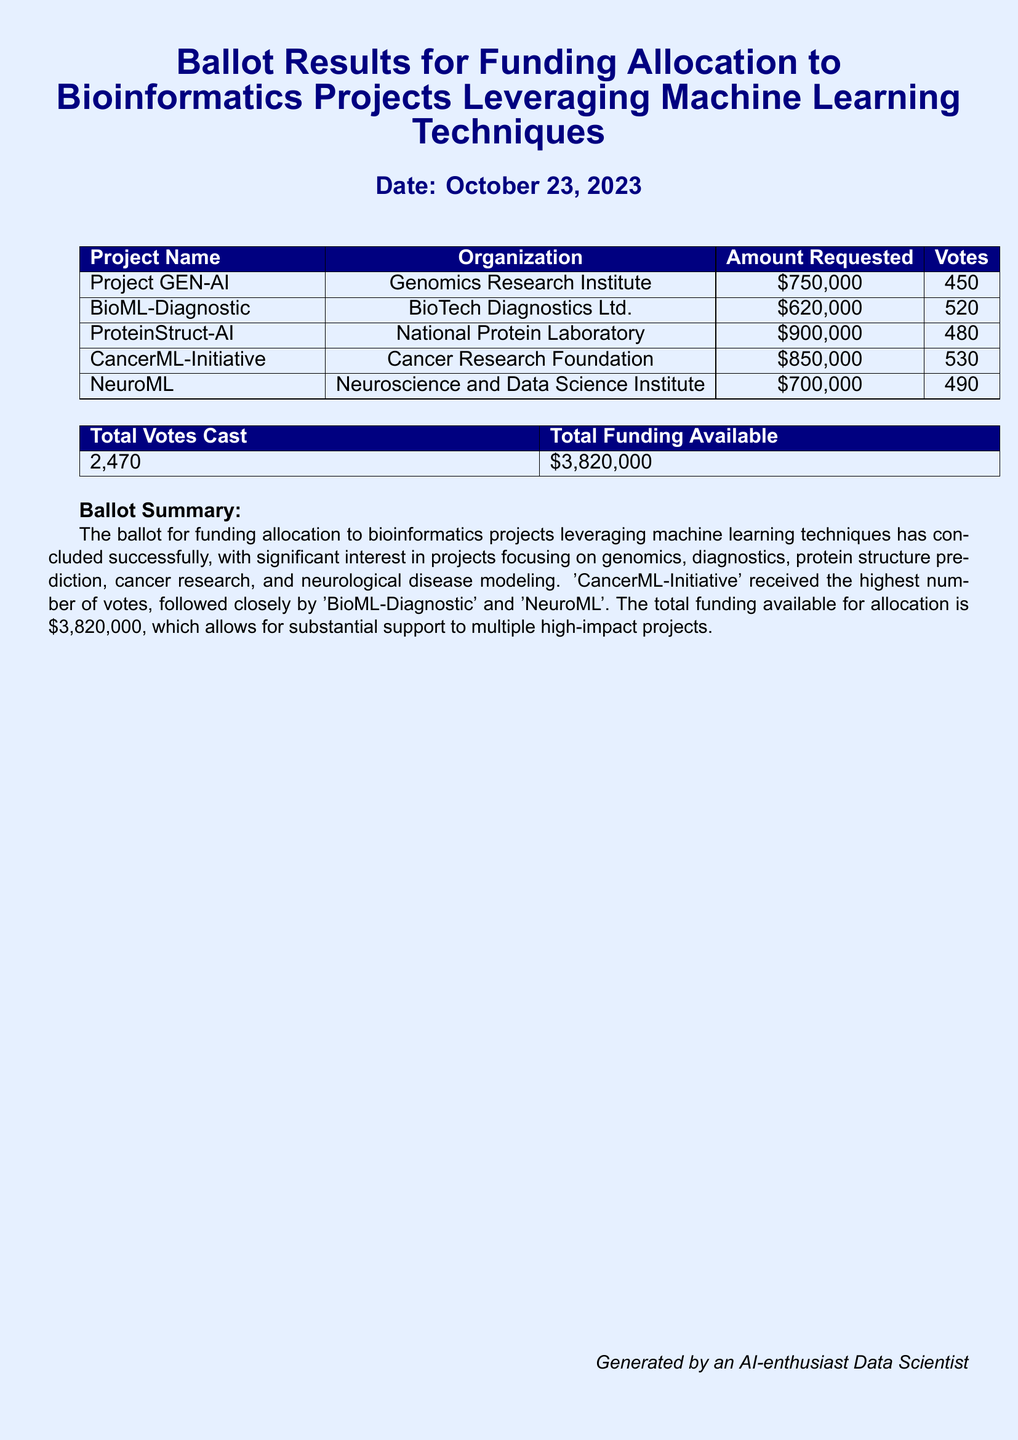What is the date of the ballot results? The date is mentioned at the top of the document.
Answer: October 23, 2023 Which project received the highest number of votes? The project with the highest votes is indicated in the results table.
Answer: CancerML-Initiative What is the total funding available? The total funding available is stated in the summary section of the document.
Answer: $3,820,000 How many total votes were cast? The total votes cast is provided in the results table.
Answer: 2,470 What organization is associated with the Project GEN-AI? The organization is listed in the results table next to the project name.
Answer: Genomics Research Institute Which project had the lowest funding request? The funding requests are listed, allowing comparison to find the lowest amount.
Answer: BioML-Diagnostic How many votes did ProteinStruct-AI receive? The number of votes for ProteinStruct-AI is shown in the results table.
Answer: 480 What project focuses on cancer research? The project related to cancer research is explicitly mentioned in the results.
Answer: CancerML-Initiative Which organization submitted a proposal for NeuroML? The organization for NeuroML is identified in the results table.
Answer: Neuroscience and Data Science Institute 